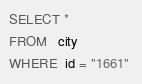Convert code to text. <code><loc_0><loc_0><loc_500><loc_500><_SQL_>SELECT * 
FROM   city 
WHERE  id = "1661" 
</code> 